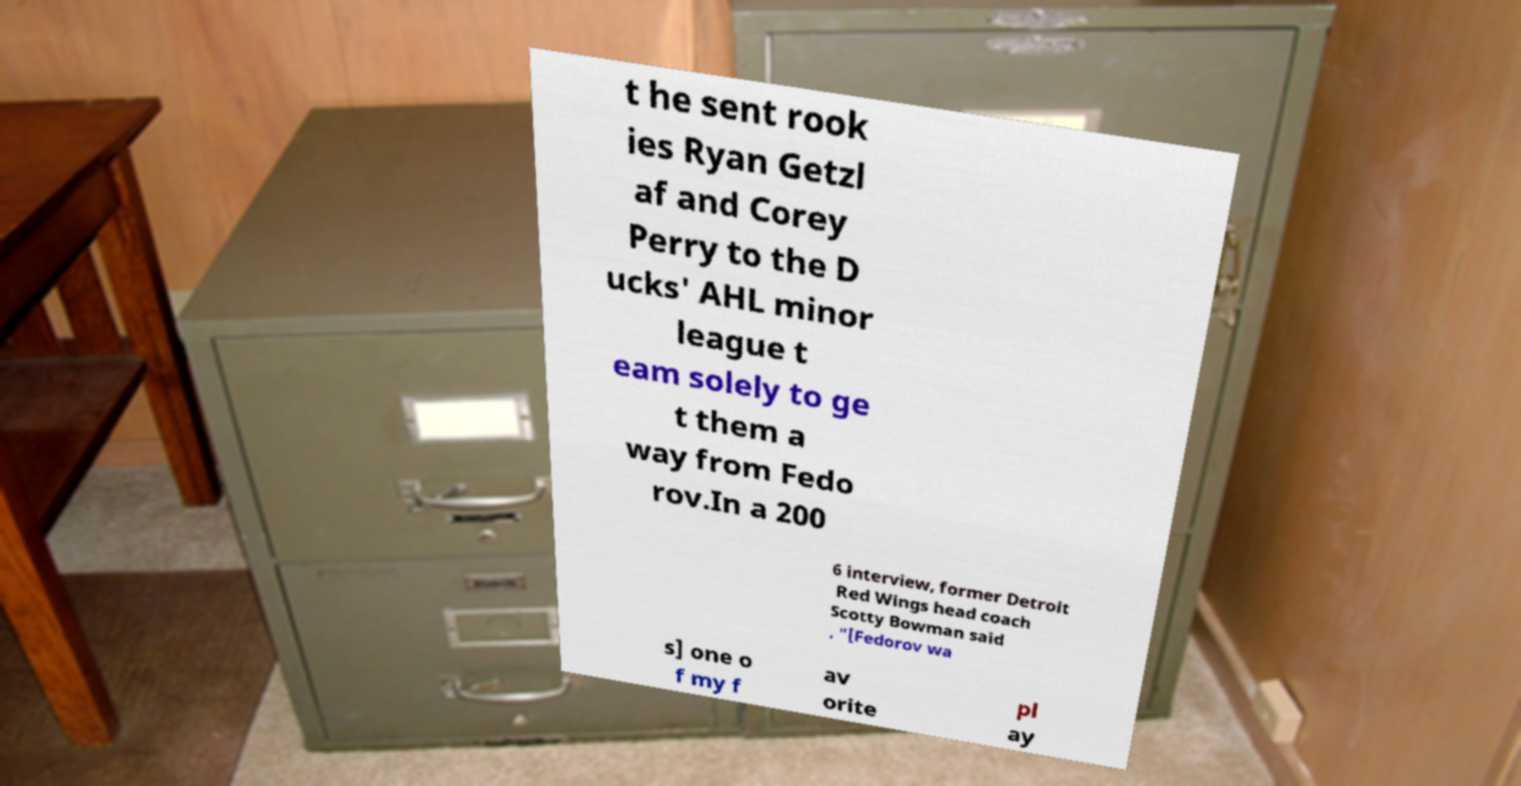Please identify and transcribe the text found in this image. t he sent rook ies Ryan Getzl af and Corey Perry to the D ucks' AHL minor league t eam solely to ge t them a way from Fedo rov.In a 200 6 interview, former Detroit Red Wings head coach Scotty Bowman said , "[Fedorov wa s] one o f my f av orite pl ay 